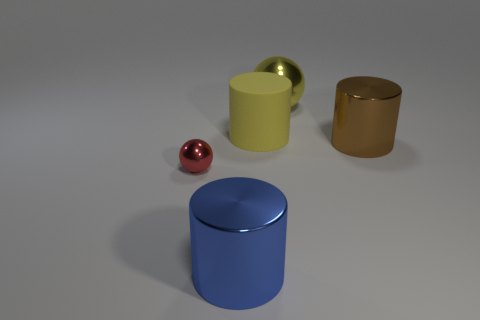There is a yellow object that is left of the yellow sphere; what is its material?
Your answer should be very brief. Rubber. The matte cylinder has what color?
Your answer should be compact. Yellow. Does the metallic thing on the left side of the blue thing have the same size as the large blue thing?
Keep it short and to the point. No. There is a yellow cylinder that is to the right of the metal cylinder on the left side of the metallic ball that is on the right side of the tiny shiny thing; what is it made of?
Your response must be concise. Rubber. Is the color of the cylinder that is behind the brown cylinder the same as the metallic sphere to the right of the blue metal cylinder?
Give a very brief answer. Yes. What material is the big yellow thing in front of the ball on the right side of the blue metal object made of?
Offer a terse response. Rubber. There is a sphere that is the same size as the yellow matte cylinder; what is its color?
Make the answer very short. Yellow. There is a tiny metallic object; is its shape the same as the object behind the large yellow rubber cylinder?
Provide a short and direct response. Yes. There is a large rubber object that is the same color as the large metallic sphere; what is its shape?
Offer a terse response. Cylinder. What number of red objects are behind the metal cylinder that is in front of the big shiny cylinder that is behind the small ball?
Ensure brevity in your answer.  1. 